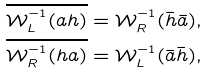<formula> <loc_0><loc_0><loc_500><loc_500>\overline { \mathcal { W } _ { L } ^ { - 1 } ( a h ) } & = \mathcal { W } _ { R } ^ { - 1 } ( \bar { h } \bar { a } ) , \\ \overline { \mathcal { W } _ { R } ^ { - 1 } ( h a ) } & = \mathcal { W } _ { L } ^ { - 1 } ( \bar { a } \bar { h } ) ,</formula> 